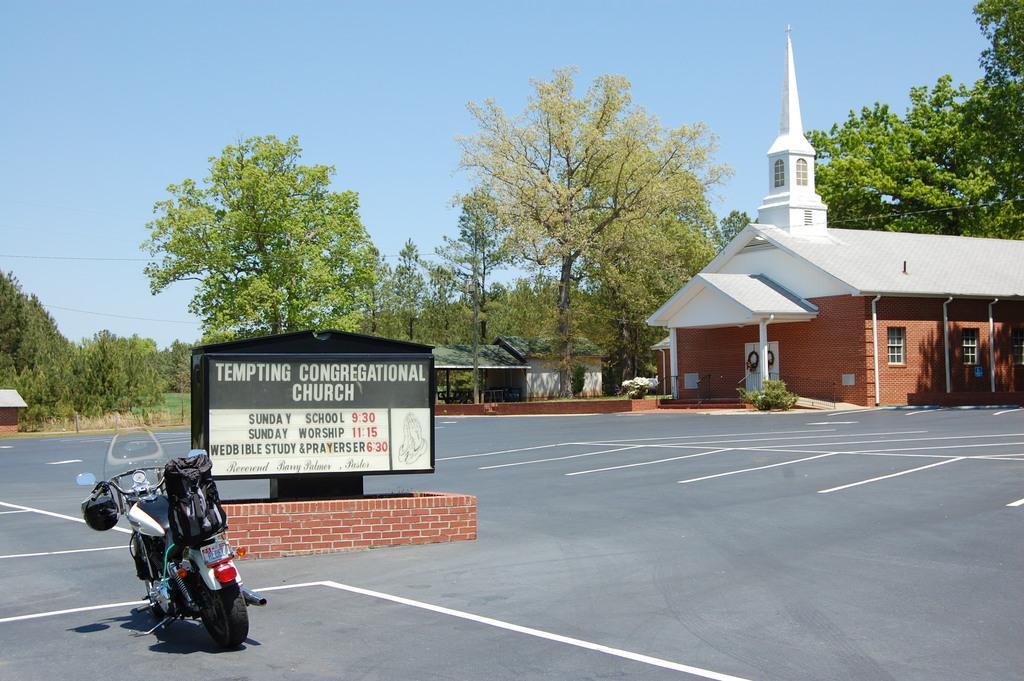In one or two sentences, can you explain what this image depicts? In this picture I can see building, trees and the sky in the background. Here I can see a board and white lines on the ground. On the left side I can see a vehicle. on the ground. 